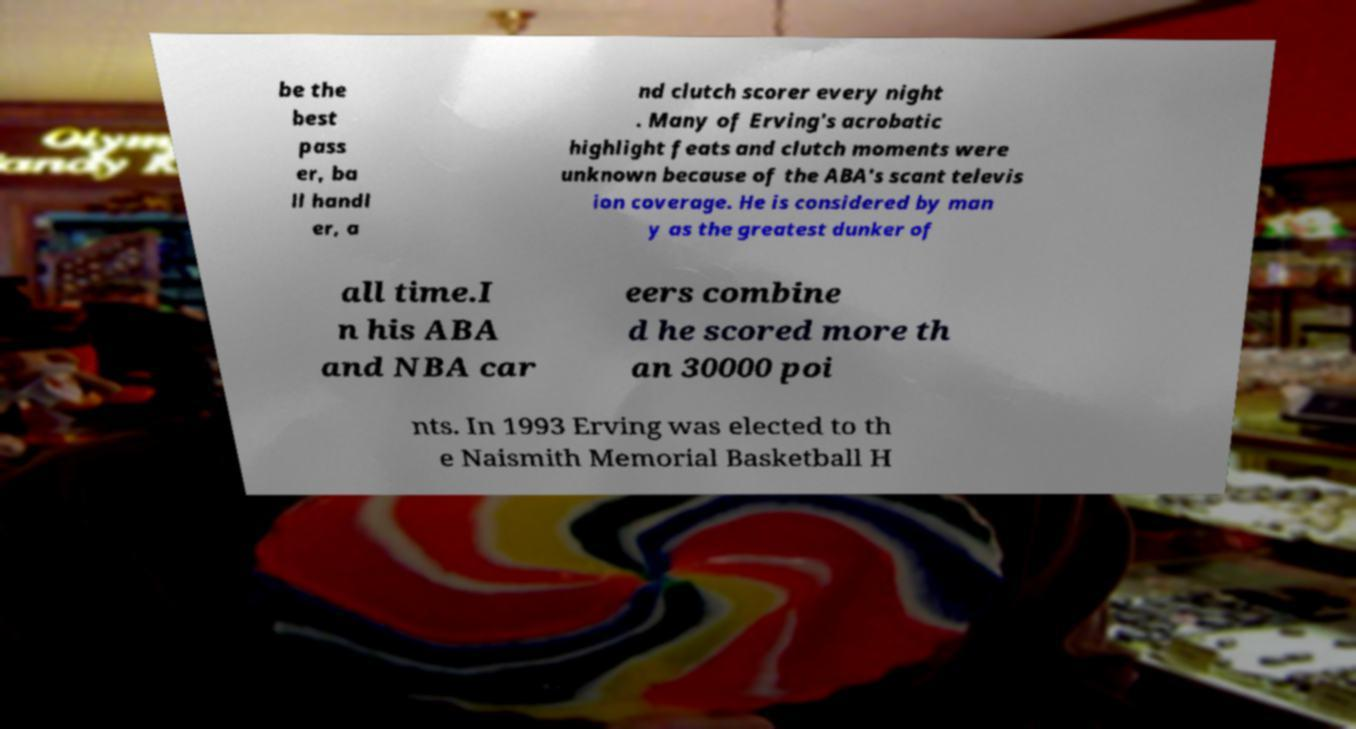I need the written content from this picture converted into text. Can you do that? be the best pass er, ba ll handl er, a nd clutch scorer every night . Many of Erving's acrobatic highlight feats and clutch moments were unknown because of the ABA's scant televis ion coverage. He is considered by man y as the greatest dunker of all time.I n his ABA and NBA car eers combine d he scored more th an 30000 poi nts. In 1993 Erving was elected to th e Naismith Memorial Basketball H 